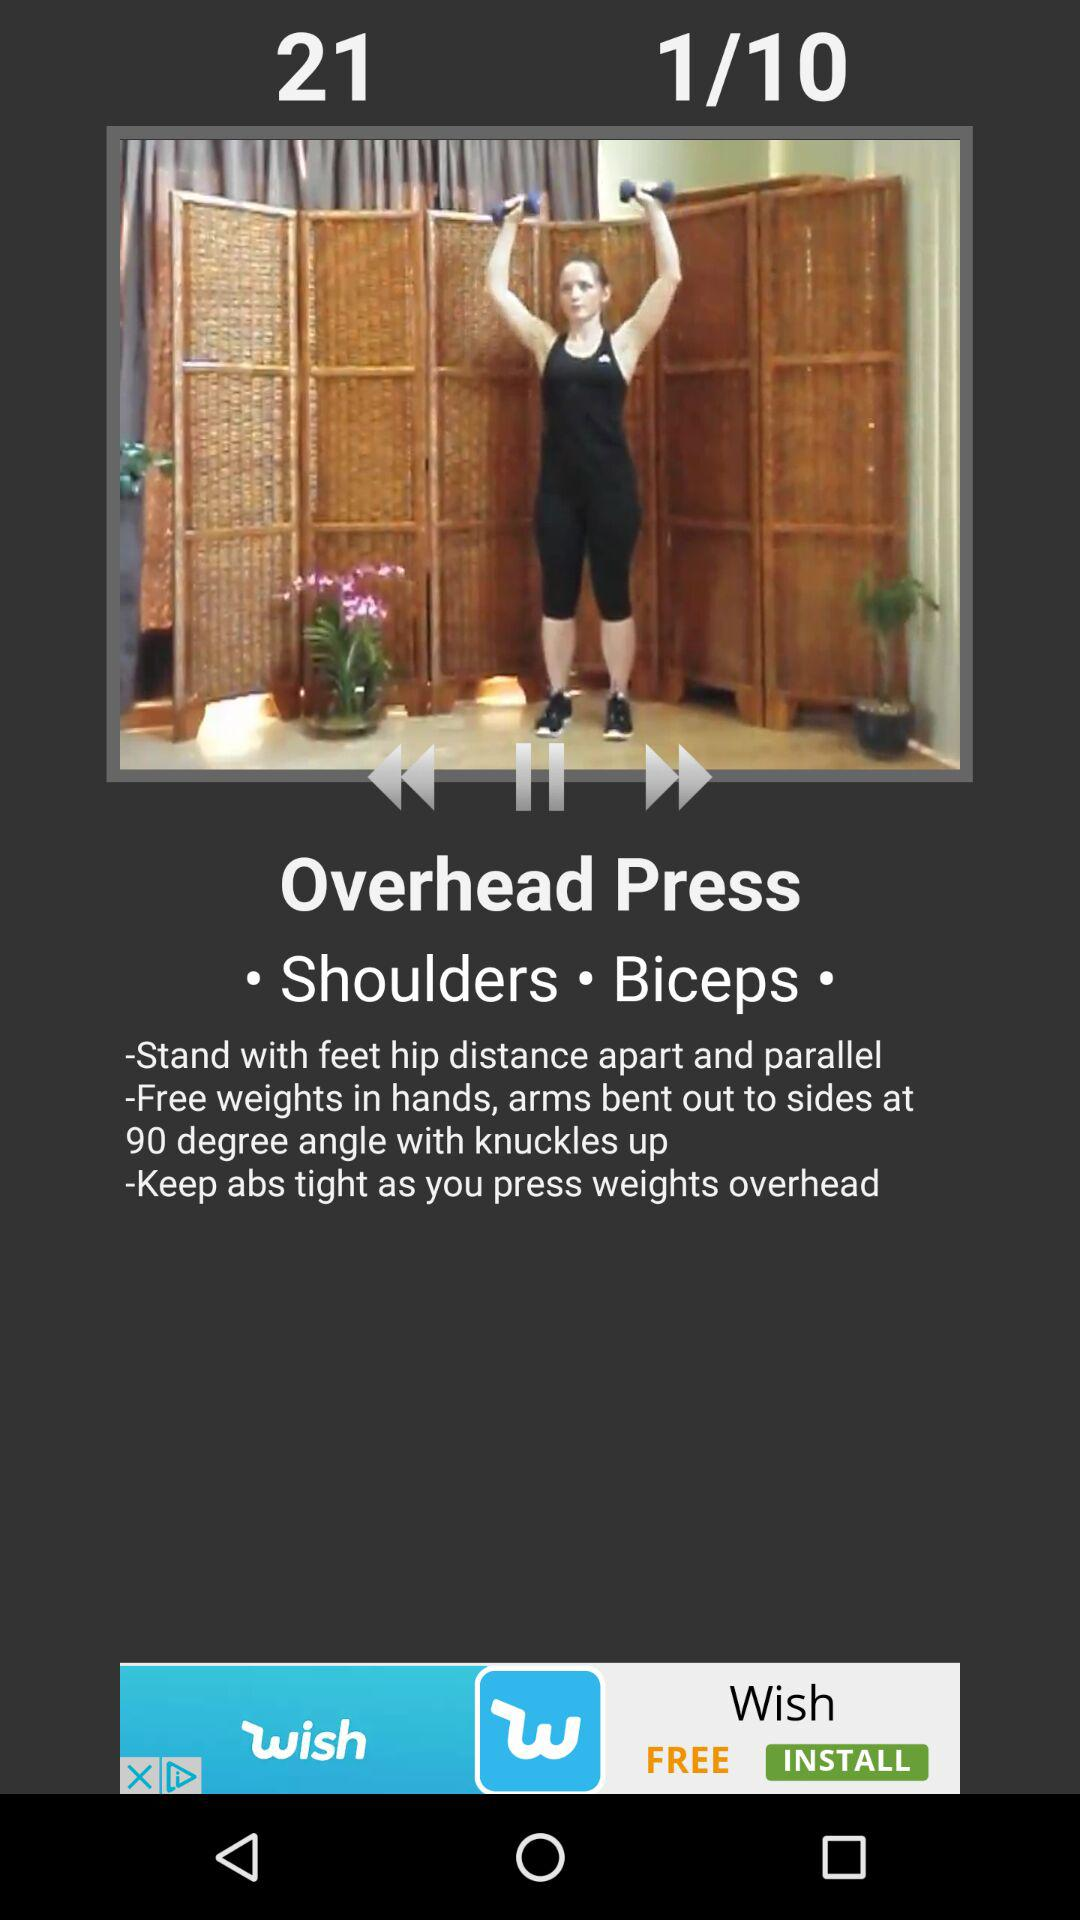How many steps are there in the exercise?
Answer the question using a single word or phrase. 3 